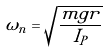Convert formula to latex. <formula><loc_0><loc_0><loc_500><loc_500>\omega _ { n } = \sqrt { \frac { m g r } { I _ { P } } }</formula> 